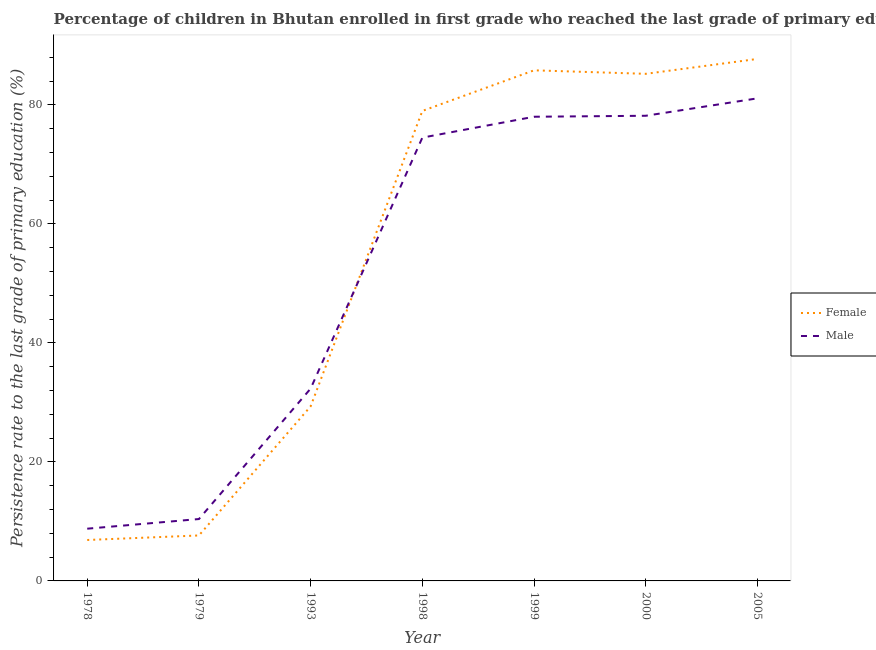Does the line corresponding to persistence rate of female students intersect with the line corresponding to persistence rate of male students?
Make the answer very short. Yes. What is the persistence rate of female students in 2005?
Keep it short and to the point. 87.74. Across all years, what is the maximum persistence rate of female students?
Ensure brevity in your answer.  87.74. Across all years, what is the minimum persistence rate of male students?
Offer a very short reply. 8.78. In which year was the persistence rate of female students maximum?
Ensure brevity in your answer.  2005. In which year was the persistence rate of female students minimum?
Ensure brevity in your answer.  1978. What is the total persistence rate of female students in the graph?
Your answer should be compact. 381.67. What is the difference between the persistence rate of male students in 1979 and that in 1993?
Ensure brevity in your answer.  -21.93. What is the difference between the persistence rate of female students in 1978 and the persistence rate of male students in 1993?
Your answer should be compact. -25.45. What is the average persistence rate of male students per year?
Make the answer very short. 51.91. In the year 1978, what is the difference between the persistence rate of female students and persistence rate of male students?
Offer a very short reply. -1.9. What is the ratio of the persistence rate of male students in 1998 to that in 2005?
Your answer should be compact. 0.92. Is the persistence rate of male students in 1978 less than that in 2000?
Offer a terse response. Yes. What is the difference between the highest and the second highest persistence rate of male students?
Provide a succinct answer. 2.93. What is the difference between the highest and the lowest persistence rate of female students?
Give a very brief answer. 80.86. Is the sum of the persistence rate of female students in 1978 and 1998 greater than the maximum persistence rate of male students across all years?
Ensure brevity in your answer.  Yes. Is the persistence rate of female students strictly greater than the persistence rate of male students over the years?
Ensure brevity in your answer.  No. Is the persistence rate of male students strictly less than the persistence rate of female students over the years?
Your response must be concise. No. How many years are there in the graph?
Provide a succinct answer. 7. Does the graph contain grids?
Keep it short and to the point. No. Where does the legend appear in the graph?
Your response must be concise. Center right. What is the title of the graph?
Your response must be concise. Percentage of children in Bhutan enrolled in first grade who reached the last grade of primary education. What is the label or title of the Y-axis?
Your answer should be compact. Persistence rate to the last grade of primary education (%). What is the Persistence rate to the last grade of primary education (%) in Female in 1978?
Make the answer very short. 6.88. What is the Persistence rate to the last grade of primary education (%) in Male in 1978?
Provide a succinct answer. 8.78. What is the Persistence rate to the last grade of primary education (%) of Female in 1979?
Make the answer very short. 7.64. What is the Persistence rate to the last grade of primary education (%) in Male in 1979?
Give a very brief answer. 10.4. What is the Persistence rate to the last grade of primary education (%) of Female in 1993?
Offer a terse response. 29.35. What is the Persistence rate to the last grade of primary education (%) in Male in 1993?
Provide a succinct answer. 32.33. What is the Persistence rate to the last grade of primary education (%) of Female in 1998?
Give a very brief answer. 79. What is the Persistence rate to the last grade of primary education (%) in Male in 1998?
Offer a terse response. 74.51. What is the Persistence rate to the last grade of primary education (%) of Female in 1999?
Provide a short and direct response. 85.83. What is the Persistence rate to the last grade of primary education (%) in Male in 1999?
Your answer should be compact. 78.02. What is the Persistence rate to the last grade of primary education (%) of Female in 2000?
Offer a very short reply. 85.24. What is the Persistence rate to the last grade of primary education (%) of Male in 2000?
Provide a short and direct response. 78.19. What is the Persistence rate to the last grade of primary education (%) of Female in 2005?
Your answer should be very brief. 87.74. What is the Persistence rate to the last grade of primary education (%) in Male in 2005?
Your response must be concise. 81.12. Across all years, what is the maximum Persistence rate to the last grade of primary education (%) in Female?
Ensure brevity in your answer.  87.74. Across all years, what is the maximum Persistence rate to the last grade of primary education (%) in Male?
Provide a short and direct response. 81.12. Across all years, what is the minimum Persistence rate to the last grade of primary education (%) in Female?
Provide a short and direct response. 6.88. Across all years, what is the minimum Persistence rate to the last grade of primary education (%) in Male?
Your response must be concise. 8.78. What is the total Persistence rate to the last grade of primary education (%) in Female in the graph?
Ensure brevity in your answer.  381.67. What is the total Persistence rate to the last grade of primary education (%) of Male in the graph?
Make the answer very short. 363.35. What is the difference between the Persistence rate to the last grade of primary education (%) of Female in 1978 and that in 1979?
Your answer should be compact. -0.76. What is the difference between the Persistence rate to the last grade of primary education (%) of Male in 1978 and that in 1979?
Your response must be concise. -1.62. What is the difference between the Persistence rate to the last grade of primary education (%) in Female in 1978 and that in 1993?
Your response must be concise. -22.47. What is the difference between the Persistence rate to the last grade of primary education (%) in Male in 1978 and that in 1993?
Your response must be concise. -23.55. What is the difference between the Persistence rate to the last grade of primary education (%) in Female in 1978 and that in 1998?
Offer a very short reply. -72.12. What is the difference between the Persistence rate to the last grade of primary education (%) in Male in 1978 and that in 1998?
Make the answer very short. -65.74. What is the difference between the Persistence rate to the last grade of primary education (%) in Female in 1978 and that in 1999?
Ensure brevity in your answer.  -78.95. What is the difference between the Persistence rate to the last grade of primary education (%) in Male in 1978 and that in 1999?
Offer a very short reply. -69.24. What is the difference between the Persistence rate to the last grade of primary education (%) of Female in 1978 and that in 2000?
Keep it short and to the point. -78.36. What is the difference between the Persistence rate to the last grade of primary education (%) of Male in 1978 and that in 2000?
Your answer should be compact. -69.41. What is the difference between the Persistence rate to the last grade of primary education (%) in Female in 1978 and that in 2005?
Keep it short and to the point. -80.86. What is the difference between the Persistence rate to the last grade of primary education (%) of Male in 1978 and that in 2005?
Offer a terse response. -72.34. What is the difference between the Persistence rate to the last grade of primary education (%) of Female in 1979 and that in 1993?
Make the answer very short. -21.71. What is the difference between the Persistence rate to the last grade of primary education (%) in Male in 1979 and that in 1993?
Give a very brief answer. -21.93. What is the difference between the Persistence rate to the last grade of primary education (%) of Female in 1979 and that in 1998?
Offer a very short reply. -71.36. What is the difference between the Persistence rate to the last grade of primary education (%) in Male in 1979 and that in 1998?
Your response must be concise. -64.11. What is the difference between the Persistence rate to the last grade of primary education (%) in Female in 1979 and that in 1999?
Your answer should be very brief. -78.18. What is the difference between the Persistence rate to the last grade of primary education (%) in Male in 1979 and that in 1999?
Give a very brief answer. -67.62. What is the difference between the Persistence rate to the last grade of primary education (%) in Female in 1979 and that in 2000?
Your answer should be very brief. -77.6. What is the difference between the Persistence rate to the last grade of primary education (%) in Male in 1979 and that in 2000?
Your answer should be very brief. -67.79. What is the difference between the Persistence rate to the last grade of primary education (%) of Female in 1979 and that in 2005?
Provide a succinct answer. -80.1. What is the difference between the Persistence rate to the last grade of primary education (%) in Male in 1979 and that in 2005?
Your response must be concise. -70.71. What is the difference between the Persistence rate to the last grade of primary education (%) in Female in 1993 and that in 1998?
Your answer should be compact. -49.65. What is the difference between the Persistence rate to the last grade of primary education (%) in Male in 1993 and that in 1998?
Keep it short and to the point. -42.18. What is the difference between the Persistence rate to the last grade of primary education (%) of Female in 1993 and that in 1999?
Offer a very short reply. -56.48. What is the difference between the Persistence rate to the last grade of primary education (%) of Male in 1993 and that in 1999?
Make the answer very short. -45.69. What is the difference between the Persistence rate to the last grade of primary education (%) in Female in 1993 and that in 2000?
Offer a very short reply. -55.89. What is the difference between the Persistence rate to the last grade of primary education (%) of Male in 1993 and that in 2000?
Make the answer very short. -45.86. What is the difference between the Persistence rate to the last grade of primary education (%) of Female in 1993 and that in 2005?
Keep it short and to the point. -58.39. What is the difference between the Persistence rate to the last grade of primary education (%) of Male in 1993 and that in 2005?
Provide a short and direct response. -48.79. What is the difference between the Persistence rate to the last grade of primary education (%) in Female in 1998 and that in 1999?
Provide a succinct answer. -6.82. What is the difference between the Persistence rate to the last grade of primary education (%) in Male in 1998 and that in 1999?
Your answer should be compact. -3.51. What is the difference between the Persistence rate to the last grade of primary education (%) in Female in 1998 and that in 2000?
Provide a short and direct response. -6.24. What is the difference between the Persistence rate to the last grade of primary education (%) of Male in 1998 and that in 2000?
Give a very brief answer. -3.67. What is the difference between the Persistence rate to the last grade of primary education (%) in Female in 1998 and that in 2005?
Your response must be concise. -8.74. What is the difference between the Persistence rate to the last grade of primary education (%) in Male in 1998 and that in 2005?
Your answer should be compact. -6.6. What is the difference between the Persistence rate to the last grade of primary education (%) of Female in 1999 and that in 2000?
Provide a short and direct response. 0.59. What is the difference between the Persistence rate to the last grade of primary education (%) in Male in 1999 and that in 2000?
Keep it short and to the point. -0.16. What is the difference between the Persistence rate to the last grade of primary education (%) in Female in 1999 and that in 2005?
Provide a succinct answer. -1.92. What is the difference between the Persistence rate to the last grade of primary education (%) in Male in 1999 and that in 2005?
Your answer should be compact. -3.09. What is the difference between the Persistence rate to the last grade of primary education (%) in Female in 2000 and that in 2005?
Ensure brevity in your answer.  -2.5. What is the difference between the Persistence rate to the last grade of primary education (%) in Male in 2000 and that in 2005?
Your answer should be very brief. -2.93. What is the difference between the Persistence rate to the last grade of primary education (%) in Female in 1978 and the Persistence rate to the last grade of primary education (%) in Male in 1979?
Your answer should be compact. -3.52. What is the difference between the Persistence rate to the last grade of primary education (%) of Female in 1978 and the Persistence rate to the last grade of primary education (%) of Male in 1993?
Your answer should be very brief. -25.45. What is the difference between the Persistence rate to the last grade of primary education (%) of Female in 1978 and the Persistence rate to the last grade of primary education (%) of Male in 1998?
Keep it short and to the point. -67.64. What is the difference between the Persistence rate to the last grade of primary education (%) in Female in 1978 and the Persistence rate to the last grade of primary education (%) in Male in 1999?
Offer a terse response. -71.14. What is the difference between the Persistence rate to the last grade of primary education (%) in Female in 1978 and the Persistence rate to the last grade of primary education (%) in Male in 2000?
Your answer should be compact. -71.31. What is the difference between the Persistence rate to the last grade of primary education (%) in Female in 1978 and the Persistence rate to the last grade of primary education (%) in Male in 2005?
Your answer should be compact. -74.24. What is the difference between the Persistence rate to the last grade of primary education (%) of Female in 1979 and the Persistence rate to the last grade of primary education (%) of Male in 1993?
Make the answer very short. -24.69. What is the difference between the Persistence rate to the last grade of primary education (%) of Female in 1979 and the Persistence rate to the last grade of primary education (%) of Male in 1998?
Offer a terse response. -66.87. What is the difference between the Persistence rate to the last grade of primary education (%) of Female in 1979 and the Persistence rate to the last grade of primary education (%) of Male in 1999?
Make the answer very short. -70.38. What is the difference between the Persistence rate to the last grade of primary education (%) in Female in 1979 and the Persistence rate to the last grade of primary education (%) in Male in 2000?
Your answer should be compact. -70.55. What is the difference between the Persistence rate to the last grade of primary education (%) of Female in 1979 and the Persistence rate to the last grade of primary education (%) of Male in 2005?
Make the answer very short. -73.48. What is the difference between the Persistence rate to the last grade of primary education (%) in Female in 1993 and the Persistence rate to the last grade of primary education (%) in Male in 1998?
Offer a terse response. -45.17. What is the difference between the Persistence rate to the last grade of primary education (%) in Female in 1993 and the Persistence rate to the last grade of primary education (%) in Male in 1999?
Offer a very short reply. -48.68. What is the difference between the Persistence rate to the last grade of primary education (%) of Female in 1993 and the Persistence rate to the last grade of primary education (%) of Male in 2000?
Give a very brief answer. -48.84. What is the difference between the Persistence rate to the last grade of primary education (%) in Female in 1993 and the Persistence rate to the last grade of primary education (%) in Male in 2005?
Your answer should be very brief. -51.77. What is the difference between the Persistence rate to the last grade of primary education (%) of Female in 1998 and the Persistence rate to the last grade of primary education (%) of Male in 1999?
Offer a terse response. 0.98. What is the difference between the Persistence rate to the last grade of primary education (%) in Female in 1998 and the Persistence rate to the last grade of primary education (%) in Male in 2000?
Provide a succinct answer. 0.81. What is the difference between the Persistence rate to the last grade of primary education (%) in Female in 1998 and the Persistence rate to the last grade of primary education (%) in Male in 2005?
Provide a short and direct response. -2.12. What is the difference between the Persistence rate to the last grade of primary education (%) of Female in 1999 and the Persistence rate to the last grade of primary education (%) of Male in 2000?
Provide a succinct answer. 7.64. What is the difference between the Persistence rate to the last grade of primary education (%) in Female in 1999 and the Persistence rate to the last grade of primary education (%) in Male in 2005?
Your answer should be very brief. 4.71. What is the difference between the Persistence rate to the last grade of primary education (%) in Female in 2000 and the Persistence rate to the last grade of primary education (%) in Male in 2005?
Ensure brevity in your answer.  4.12. What is the average Persistence rate to the last grade of primary education (%) in Female per year?
Give a very brief answer. 54.52. What is the average Persistence rate to the last grade of primary education (%) of Male per year?
Your response must be concise. 51.91. In the year 1978, what is the difference between the Persistence rate to the last grade of primary education (%) in Female and Persistence rate to the last grade of primary education (%) in Male?
Your answer should be very brief. -1.9. In the year 1979, what is the difference between the Persistence rate to the last grade of primary education (%) of Female and Persistence rate to the last grade of primary education (%) of Male?
Your response must be concise. -2.76. In the year 1993, what is the difference between the Persistence rate to the last grade of primary education (%) of Female and Persistence rate to the last grade of primary education (%) of Male?
Your answer should be compact. -2.98. In the year 1998, what is the difference between the Persistence rate to the last grade of primary education (%) in Female and Persistence rate to the last grade of primary education (%) in Male?
Offer a terse response. 4.49. In the year 1999, what is the difference between the Persistence rate to the last grade of primary education (%) in Female and Persistence rate to the last grade of primary education (%) in Male?
Ensure brevity in your answer.  7.8. In the year 2000, what is the difference between the Persistence rate to the last grade of primary education (%) of Female and Persistence rate to the last grade of primary education (%) of Male?
Give a very brief answer. 7.05. In the year 2005, what is the difference between the Persistence rate to the last grade of primary education (%) of Female and Persistence rate to the last grade of primary education (%) of Male?
Your answer should be very brief. 6.62. What is the ratio of the Persistence rate to the last grade of primary education (%) of Female in 1978 to that in 1979?
Give a very brief answer. 0.9. What is the ratio of the Persistence rate to the last grade of primary education (%) in Male in 1978 to that in 1979?
Your answer should be compact. 0.84. What is the ratio of the Persistence rate to the last grade of primary education (%) of Female in 1978 to that in 1993?
Provide a short and direct response. 0.23. What is the ratio of the Persistence rate to the last grade of primary education (%) in Male in 1978 to that in 1993?
Offer a terse response. 0.27. What is the ratio of the Persistence rate to the last grade of primary education (%) of Female in 1978 to that in 1998?
Your answer should be compact. 0.09. What is the ratio of the Persistence rate to the last grade of primary education (%) of Male in 1978 to that in 1998?
Ensure brevity in your answer.  0.12. What is the ratio of the Persistence rate to the last grade of primary education (%) in Female in 1978 to that in 1999?
Offer a very short reply. 0.08. What is the ratio of the Persistence rate to the last grade of primary education (%) of Male in 1978 to that in 1999?
Provide a short and direct response. 0.11. What is the ratio of the Persistence rate to the last grade of primary education (%) in Female in 1978 to that in 2000?
Offer a terse response. 0.08. What is the ratio of the Persistence rate to the last grade of primary education (%) in Male in 1978 to that in 2000?
Give a very brief answer. 0.11. What is the ratio of the Persistence rate to the last grade of primary education (%) in Female in 1978 to that in 2005?
Your answer should be very brief. 0.08. What is the ratio of the Persistence rate to the last grade of primary education (%) in Male in 1978 to that in 2005?
Ensure brevity in your answer.  0.11. What is the ratio of the Persistence rate to the last grade of primary education (%) in Female in 1979 to that in 1993?
Your answer should be very brief. 0.26. What is the ratio of the Persistence rate to the last grade of primary education (%) in Male in 1979 to that in 1993?
Ensure brevity in your answer.  0.32. What is the ratio of the Persistence rate to the last grade of primary education (%) in Female in 1979 to that in 1998?
Offer a terse response. 0.1. What is the ratio of the Persistence rate to the last grade of primary education (%) in Male in 1979 to that in 1998?
Keep it short and to the point. 0.14. What is the ratio of the Persistence rate to the last grade of primary education (%) of Female in 1979 to that in 1999?
Your response must be concise. 0.09. What is the ratio of the Persistence rate to the last grade of primary education (%) of Male in 1979 to that in 1999?
Keep it short and to the point. 0.13. What is the ratio of the Persistence rate to the last grade of primary education (%) in Female in 1979 to that in 2000?
Your answer should be very brief. 0.09. What is the ratio of the Persistence rate to the last grade of primary education (%) of Male in 1979 to that in 2000?
Provide a succinct answer. 0.13. What is the ratio of the Persistence rate to the last grade of primary education (%) in Female in 1979 to that in 2005?
Offer a very short reply. 0.09. What is the ratio of the Persistence rate to the last grade of primary education (%) in Male in 1979 to that in 2005?
Provide a succinct answer. 0.13. What is the ratio of the Persistence rate to the last grade of primary education (%) in Female in 1993 to that in 1998?
Provide a succinct answer. 0.37. What is the ratio of the Persistence rate to the last grade of primary education (%) of Male in 1993 to that in 1998?
Provide a short and direct response. 0.43. What is the ratio of the Persistence rate to the last grade of primary education (%) of Female in 1993 to that in 1999?
Your response must be concise. 0.34. What is the ratio of the Persistence rate to the last grade of primary education (%) of Male in 1993 to that in 1999?
Your answer should be very brief. 0.41. What is the ratio of the Persistence rate to the last grade of primary education (%) in Female in 1993 to that in 2000?
Offer a terse response. 0.34. What is the ratio of the Persistence rate to the last grade of primary education (%) of Male in 1993 to that in 2000?
Provide a short and direct response. 0.41. What is the ratio of the Persistence rate to the last grade of primary education (%) in Female in 1993 to that in 2005?
Provide a short and direct response. 0.33. What is the ratio of the Persistence rate to the last grade of primary education (%) in Male in 1993 to that in 2005?
Provide a succinct answer. 0.4. What is the ratio of the Persistence rate to the last grade of primary education (%) of Female in 1998 to that in 1999?
Your response must be concise. 0.92. What is the ratio of the Persistence rate to the last grade of primary education (%) in Male in 1998 to that in 1999?
Provide a succinct answer. 0.95. What is the ratio of the Persistence rate to the last grade of primary education (%) of Female in 1998 to that in 2000?
Provide a succinct answer. 0.93. What is the ratio of the Persistence rate to the last grade of primary education (%) in Male in 1998 to that in 2000?
Give a very brief answer. 0.95. What is the ratio of the Persistence rate to the last grade of primary education (%) of Female in 1998 to that in 2005?
Provide a short and direct response. 0.9. What is the ratio of the Persistence rate to the last grade of primary education (%) of Male in 1998 to that in 2005?
Give a very brief answer. 0.92. What is the ratio of the Persistence rate to the last grade of primary education (%) in Female in 1999 to that in 2000?
Keep it short and to the point. 1.01. What is the ratio of the Persistence rate to the last grade of primary education (%) of Male in 1999 to that in 2000?
Your answer should be compact. 1. What is the ratio of the Persistence rate to the last grade of primary education (%) of Female in 1999 to that in 2005?
Offer a terse response. 0.98. What is the ratio of the Persistence rate to the last grade of primary education (%) of Male in 1999 to that in 2005?
Offer a very short reply. 0.96. What is the ratio of the Persistence rate to the last grade of primary education (%) in Female in 2000 to that in 2005?
Give a very brief answer. 0.97. What is the ratio of the Persistence rate to the last grade of primary education (%) in Male in 2000 to that in 2005?
Your answer should be very brief. 0.96. What is the difference between the highest and the second highest Persistence rate to the last grade of primary education (%) in Female?
Provide a short and direct response. 1.92. What is the difference between the highest and the second highest Persistence rate to the last grade of primary education (%) in Male?
Ensure brevity in your answer.  2.93. What is the difference between the highest and the lowest Persistence rate to the last grade of primary education (%) of Female?
Provide a succinct answer. 80.86. What is the difference between the highest and the lowest Persistence rate to the last grade of primary education (%) in Male?
Ensure brevity in your answer.  72.34. 